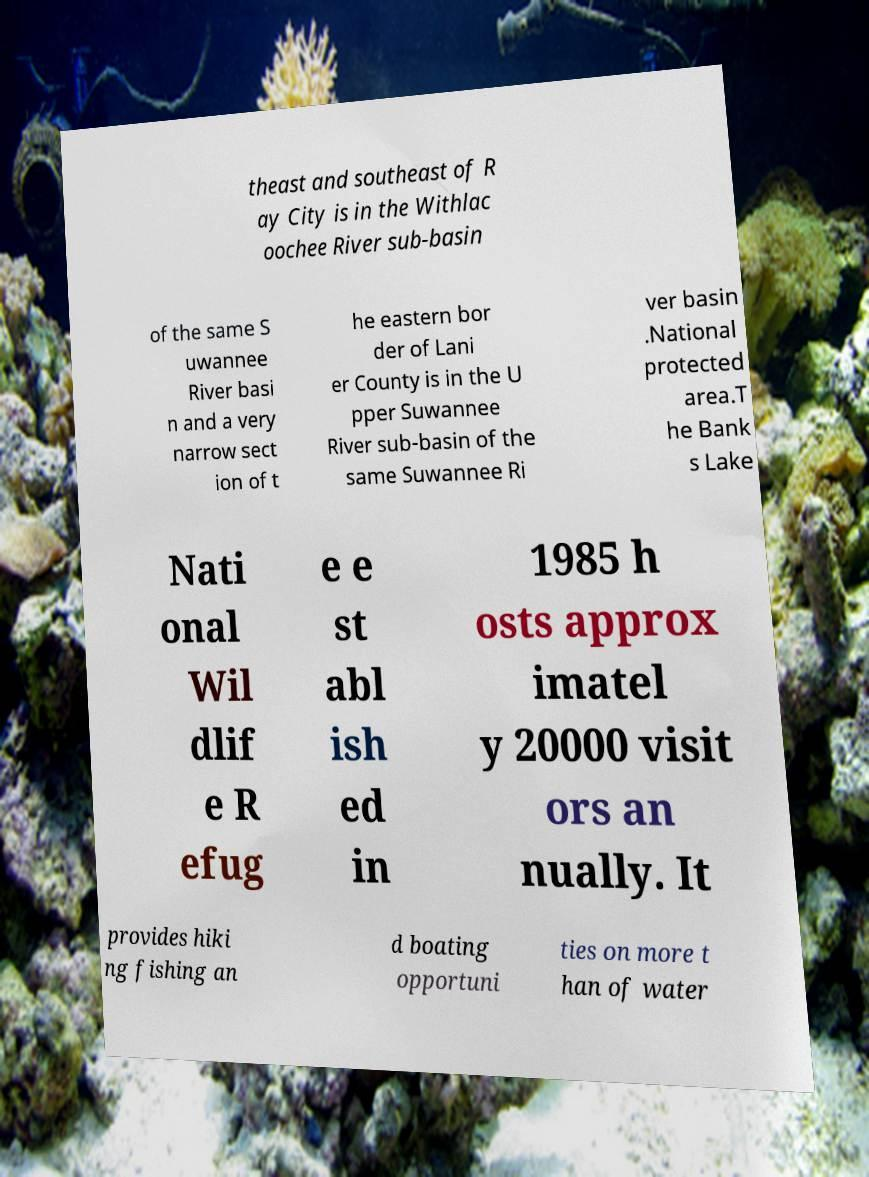Could you extract and type out the text from this image? theast and southeast of R ay City is in the Withlac oochee River sub-basin of the same S uwannee River basi n and a very narrow sect ion of t he eastern bor der of Lani er County is in the U pper Suwannee River sub-basin of the same Suwannee Ri ver basin .National protected area.T he Bank s Lake Nati onal Wil dlif e R efug e e st abl ish ed in 1985 h osts approx imatel y 20000 visit ors an nually. It provides hiki ng fishing an d boating opportuni ties on more t han of water 